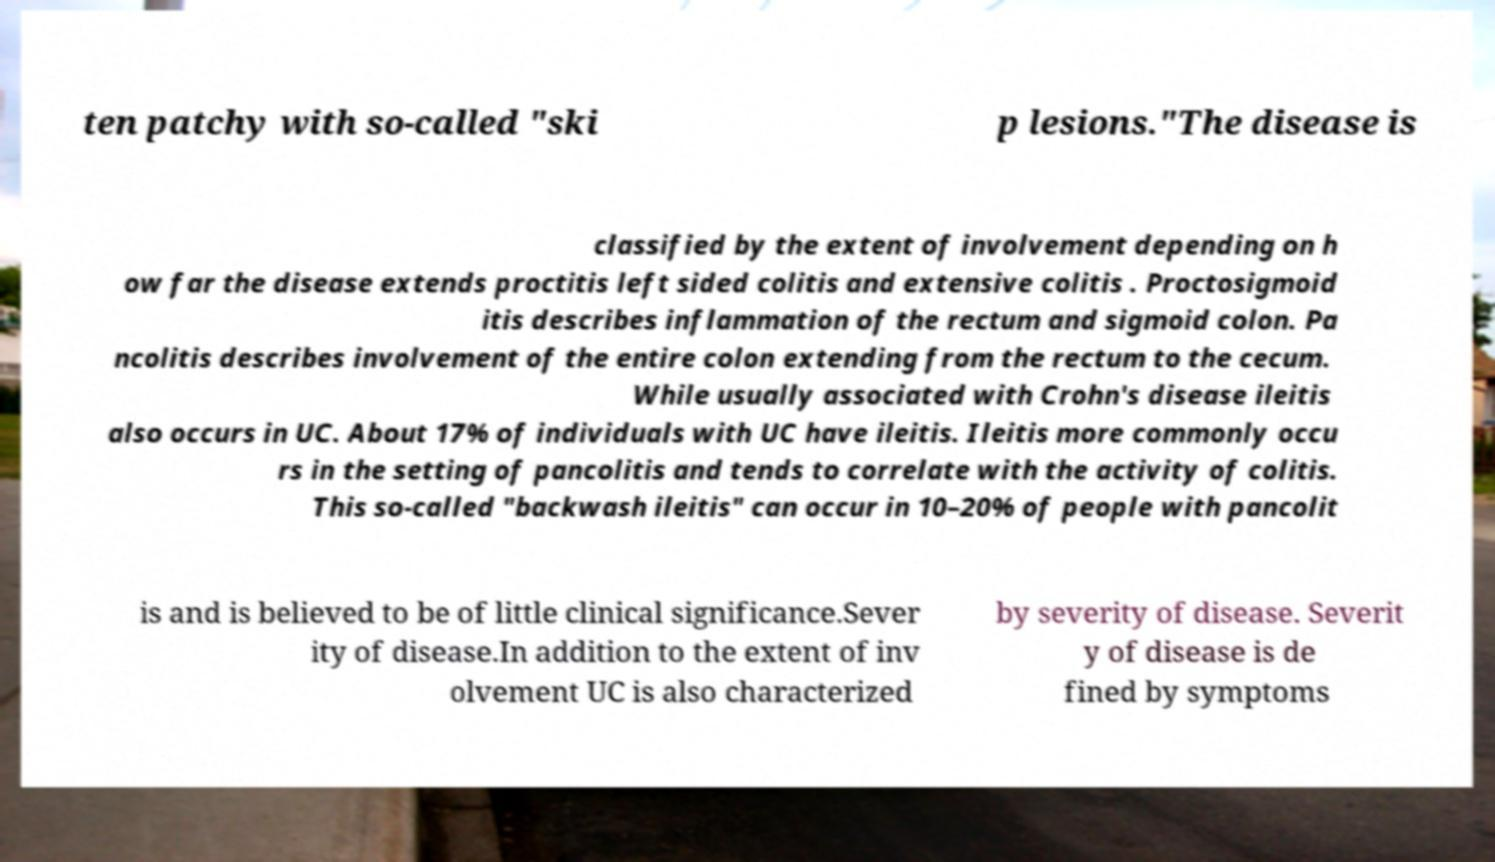There's text embedded in this image that I need extracted. Can you transcribe it verbatim? ten patchy with so-called "ski p lesions."The disease is classified by the extent of involvement depending on h ow far the disease extends proctitis left sided colitis and extensive colitis . Proctosigmoid itis describes inflammation of the rectum and sigmoid colon. Pa ncolitis describes involvement of the entire colon extending from the rectum to the cecum. While usually associated with Crohn's disease ileitis also occurs in UC. About 17% of individuals with UC have ileitis. Ileitis more commonly occu rs in the setting of pancolitis and tends to correlate with the activity of colitis. This so-called "backwash ileitis" can occur in 10–20% of people with pancolit is and is believed to be of little clinical significance.Sever ity of disease.In addition to the extent of inv olvement UC is also characterized by severity of disease. Severit y of disease is de fined by symptoms 